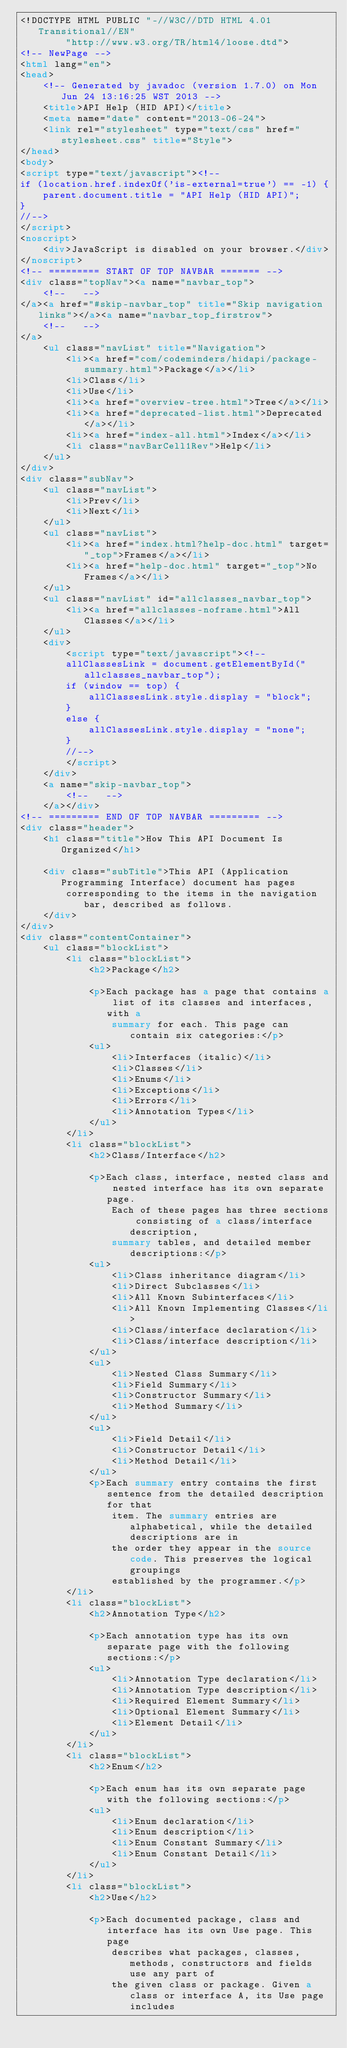<code> <loc_0><loc_0><loc_500><loc_500><_HTML_><!DOCTYPE HTML PUBLIC "-//W3C//DTD HTML 4.01 Transitional//EN"
        "http://www.w3.org/TR/html4/loose.dtd">
<!-- NewPage -->
<html lang="en">
<head>
    <!-- Generated by javadoc (version 1.7.0) on Mon Jun 24 13:16:25 WST 2013 -->
    <title>API Help (HID API)</title>
    <meta name="date" content="2013-06-24">
    <link rel="stylesheet" type="text/css" href="stylesheet.css" title="Style">
</head>
<body>
<script type="text/javascript"><!--
if (location.href.indexOf('is-external=true') == -1) {
    parent.document.title = "API Help (HID API)";
}
//-->
</script>
<noscript>
    <div>JavaScript is disabled on your browser.</div>
</noscript>
<!-- ========= START OF TOP NAVBAR ======= -->
<div class="topNav"><a name="navbar_top">
    <!--   -->
</a><a href="#skip-navbar_top" title="Skip navigation links"></a><a name="navbar_top_firstrow">
    <!--   -->
</a>
    <ul class="navList" title="Navigation">
        <li><a href="com/codeminders/hidapi/package-summary.html">Package</a></li>
        <li>Class</li>
        <li>Use</li>
        <li><a href="overview-tree.html">Tree</a></li>
        <li><a href="deprecated-list.html">Deprecated</a></li>
        <li><a href="index-all.html">Index</a></li>
        <li class="navBarCell1Rev">Help</li>
    </ul>
</div>
<div class="subNav">
    <ul class="navList">
        <li>Prev</li>
        <li>Next</li>
    </ul>
    <ul class="navList">
        <li><a href="index.html?help-doc.html" target="_top">Frames</a></li>
        <li><a href="help-doc.html" target="_top">No Frames</a></li>
    </ul>
    <ul class="navList" id="allclasses_navbar_top">
        <li><a href="allclasses-noframe.html">All Classes</a></li>
    </ul>
    <div>
        <script type="text/javascript"><!--
        allClassesLink = document.getElementById("allclasses_navbar_top");
        if (window == top) {
            allClassesLink.style.display = "block";
        }
        else {
            allClassesLink.style.display = "none";
        }
        //-->
        </script>
    </div>
    <a name="skip-navbar_top">
        <!--   -->
    </a></div>
<!-- ========= END OF TOP NAVBAR ========= -->
<div class="header">
    <h1 class="title">How This API Document Is Organized</h1>

    <div class="subTitle">This API (Application Programming Interface) document has pages
        corresponding to the items in the navigation bar, described as follows.
    </div>
</div>
<div class="contentContainer">
    <ul class="blockList">
        <li class="blockList">
            <h2>Package</h2>

            <p>Each package has a page that contains a list of its classes and interfaces, with a
                summary for each. This page can contain six categories:</p>
            <ul>
                <li>Interfaces (italic)</li>
                <li>Classes</li>
                <li>Enums</li>
                <li>Exceptions</li>
                <li>Errors</li>
                <li>Annotation Types</li>
            </ul>
        </li>
        <li class="blockList">
            <h2>Class/Interface</h2>

            <p>Each class, interface, nested class and nested interface has its own separate page.
                Each of these pages has three sections consisting of a class/interface description,
                summary tables, and detailed member descriptions:</p>
            <ul>
                <li>Class inheritance diagram</li>
                <li>Direct Subclasses</li>
                <li>All Known Subinterfaces</li>
                <li>All Known Implementing Classes</li>
                <li>Class/interface declaration</li>
                <li>Class/interface description</li>
            </ul>
            <ul>
                <li>Nested Class Summary</li>
                <li>Field Summary</li>
                <li>Constructor Summary</li>
                <li>Method Summary</li>
            </ul>
            <ul>
                <li>Field Detail</li>
                <li>Constructor Detail</li>
                <li>Method Detail</li>
            </ul>
            <p>Each summary entry contains the first sentence from the detailed description for that
                item. The summary entries are alphabetical, while the detailed descriptions are in
                the order they appear in the source code. This preserves the logical groupings
                established by the programmer.</p>
        </li>
        <li class="blockList">
            <h2>Annotation Type</h2>

            <p>Each annotation type has its own separate page with the following sections:</p>
            <ul>
                <li>Annotation Type declaration</li>
                <li>Annotation Type description</li>
                <li>Required Element Summary</li>
                <li>Optional Element Summary</li>
                <li>Element Detail</li>
            </ul>
        </li>
        <li class="blockList">
            <h2>Enum</h2>

            <p>Each enum has its own separate page with the following sections:</p>
            <ul>
                <li>Enum declaration</li>
                <li>Enum description</li>
                <li>Enum Constant Summary</li>
                <li>Enum Constant Detail</li>
            </ul>
        </li>
        <li class="blockList">
            <h2>Use</h2>

            <p>Each documented package, class and interface has its own Use page. This page
                describes what packages, classes, methods, constructors and fields use any part of
                the given class or package. Given a class or interface A, its Use page includes</code> 